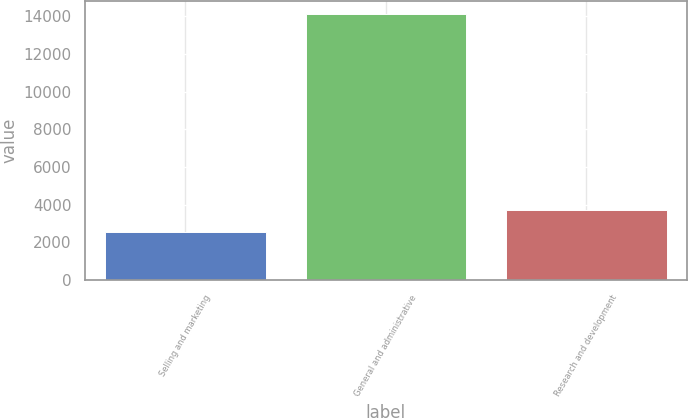Convert chart to OTSL. <chart><loc_0><loc_0><loc_500><loc_500><bar_chart><fcel>Selling and marketing<fcel>General and administrative<fcel>Research and development<nl><fcel>2551<fcel>14119<fcel>3707.8<nl></chart> 